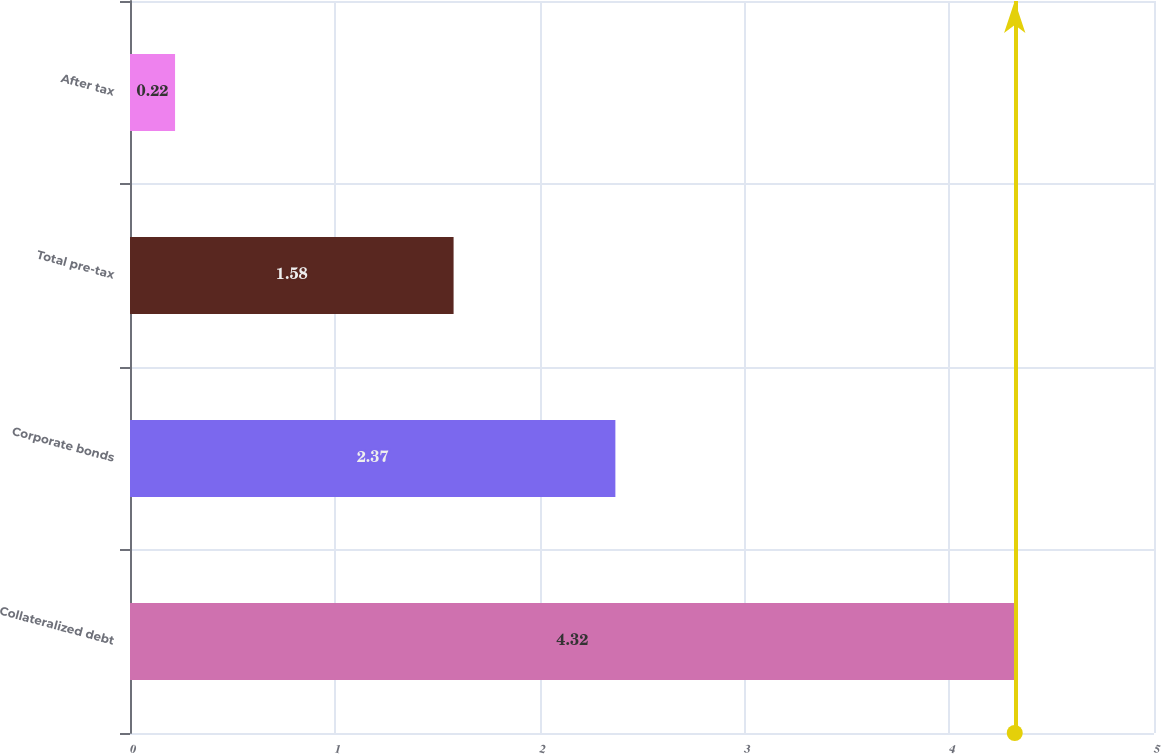<chart> <loc_0><loc_0><loc_500><loc_500><bar_chart><fcel>Collateralized debt<fcel>Corporate bonds<fcel>Total pre-tax<fcel>After tax<nl><fcel>4.32<fcel>2.37<fcel>1.58<fcel>0.22<nl></chart> 